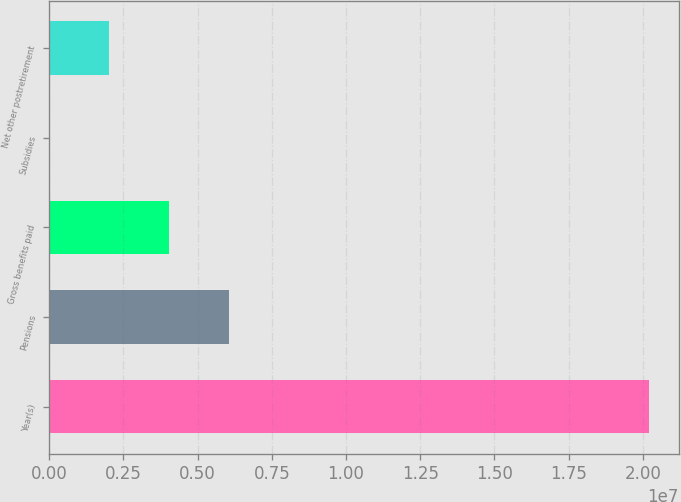<chart> <loc_0><loc_0><loc_500><loc_500><bar_chart><fcel>Year(s)<fcel>Pensions<fcel>Gross benefits paid<fcel>Subsidies<fcel>Net other postretirement<nl><fcel>2.0192e+07<fcel>6.05776e+06<fcel>4.03858e+06<fcel>215<fcel>2.0194e+06<nl></chart> 